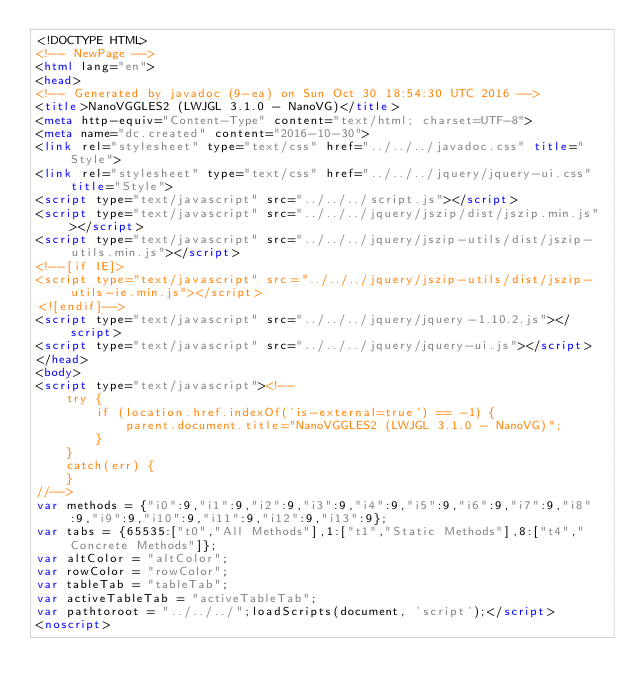<code> <loc_0><loc_0><loc_500><loc_500><_HTML_><!DOCTYPE HTML>
<!-- NewPage -->
<html lang="en">
<head>
<!-- Generated by javadoc (9-ea) on Sun Oct 30 18:54:30 UTC 2016 -->
<title>NanoVGGLES2 (LWJGL 3.1.0 - NanoVG)</title>
<meta http-equiv="Content-Type" content="text/html; charset=UTF-8">
<meta name="dc.created" content="2016-10-30">
<link rel="stylesheet" type="text/css" href="../../../javadoc.css" title="Style">
<link rel="stylesheet" type="text/css" href="../../../jquery/jquery-ui.css" title="Style">
<script type="text/javascript" src="../../../script.js"></script>
<script type="text/javascript" src="../../../jquery/jszip/dist/jszip.min.js"></script>
<script type="text/javascript" src="../../../jquery/jszip-utils/dist/jszip-utils.min.js"></script>
<!--[if IE]>
<script type="text/javascript" src="../../../jquery/jszip-utils/dist/jszip-utils-ie.min.js"></script>
<![endif]-->
<script type="text/javascript" src="../../../jquery/jquery-1.10.2.js"></script>
<script type="text/javascript" src="../../../jquery/jquery-ui.js"></script>
</head>
<body>
<script type="text/javascript"><!--
    try {
        if (location.href.indexOf('is-external=true') == -1) {
            parent.document.title="NanoVGGLES2 (LWJGL 3.1.0 - NanoVG)";
        }
    }
    catch(err) {
    }
//-->
var methods = {"i0":9,"i1":9,"i2":9,"i3":9,"i4":9,"i5":9,"i6":9,"i7":9,"i8":9,"i9":9,"i10":9,"i11":9,"i12":9,"i13":9};
var tabs = {65535:["t0","All Methods"],1:["t1","Static Methods"],8:["t4","Concrete Methods"]};
var altColor = "altColor";
var rowColor = "rowColor";
var tableTab = "tableTab";
var activeTableTab = "activeTableTab";
var pathtoroot = "../../../";loadScripts(document, 'script');</script>
<noscript></code> 